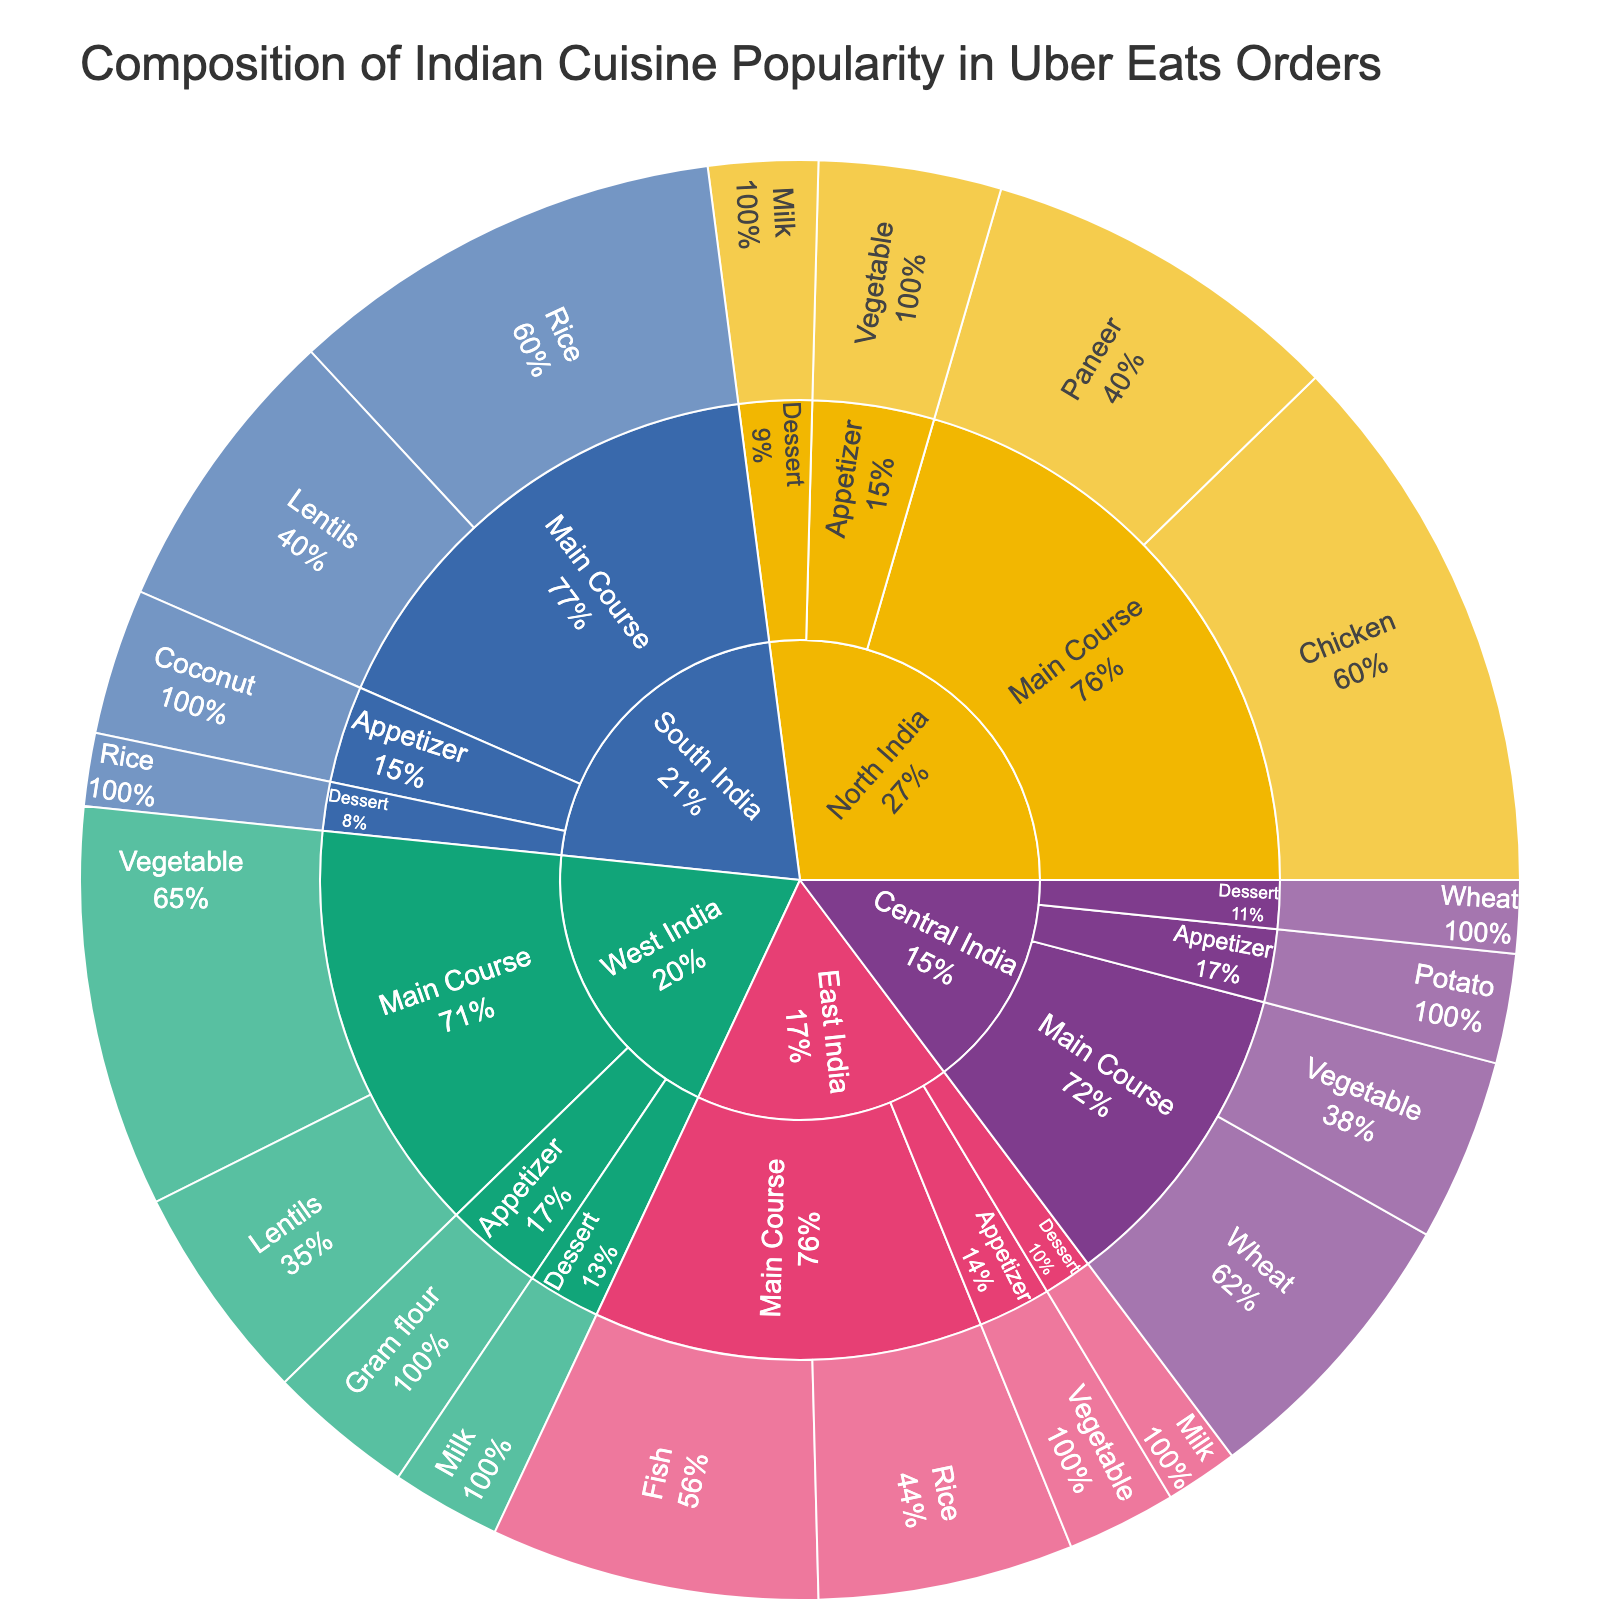What region has the highest percentage of main course orders? By examining the labels under each region for main course orders, we can see that North India has a 15% (Chicken) and 10% (Paneer) totaling 25%, which is the highest compared to other regions.
Answer: North India Which region has the lowest percentage of dessert orders? By looking at the dessert segments of each region, Central India and East India both have 2%, South India has 2%, North India has 3%, and West India has 3%. Since 2% is the lowest value, both Central India and East India have the lowest percentage of dessert orders.
Answer: Central India and East India What is the total percentage of appetizer orders across all regions? Sum the percentages of appetizer orders from each region: North India (5%) + South India (4%) + East India (3%) + West India (4%) + Central India (3%) = 19%.
Answer: 19% Compare the popularity of Paneer and Lentils as main course ingredients. Which one is more popular? Paneer has only North India (10%), while Lentils have South India (8%) and West India (6%), totaling 14%. So, Lentils are more popular.
Answer: Lentils Which region has the highest variety of primary ingredients in main courses? North India has Chicken and Paneer, South India has Rice and Lentils, East India has Fish and Rice, West India has Vegetable and Lentils, and Central India has Wheat and Vegetable. Since all regions list two primary ingredients, they are equal in variety.
Answer: All regions have equal variety What percentage of orders from North India are vegetarian (Paneer, Vegetable)? North India has Paneer for 10% and Appetizer Vegetable for 5%, totaling 15%.
Answer: 15% Which meal type has the largest combined percentage across all regions? Main Courses: 15%+10%+12%+8%+9%+7%+11%+6%+8%+5%=91%. Appetizers: 5%+4%+3%+4%+3%=19%. Desserts: 3%+2%+2%+3%+2%=12%. Main Courses clearly have the largest combined percentage.
Answer: Main Course Compare the combined percentages of milk-based desserts versus rice-based desserts. Which one is more popular? Milk-based desserts: North India (3%) + East India (2%) + West India (3%) = 8%. Rice-based desserts: South India (2%) = 2%. Milk-based desserts are more popular.
Answer: Milk-based desserts What is the percentage difference between the highest and the lowest region's main course contributions? North India has the highest with 25% (15% + 10%), and Central and East India each have the lowest with 13% (8% + 5% or 9% + 4%). The difference is 25% - 13% = 12%.
Answer: 12% 